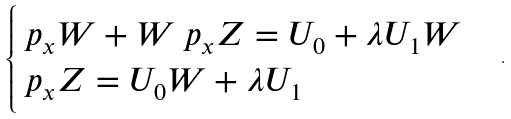Convert formula to latex. <formula><loc_0><loc_0><loc_500><loc_500>\begin{cases} \ p _ { x } W + W \ p _ { x } Z = U _ { 0 } + \lambda U _ { 1 } W \\ \ p _ { x } Z = U _ { 0 } W + \lambda U _ { 1 } \end{cases} .</formula> 